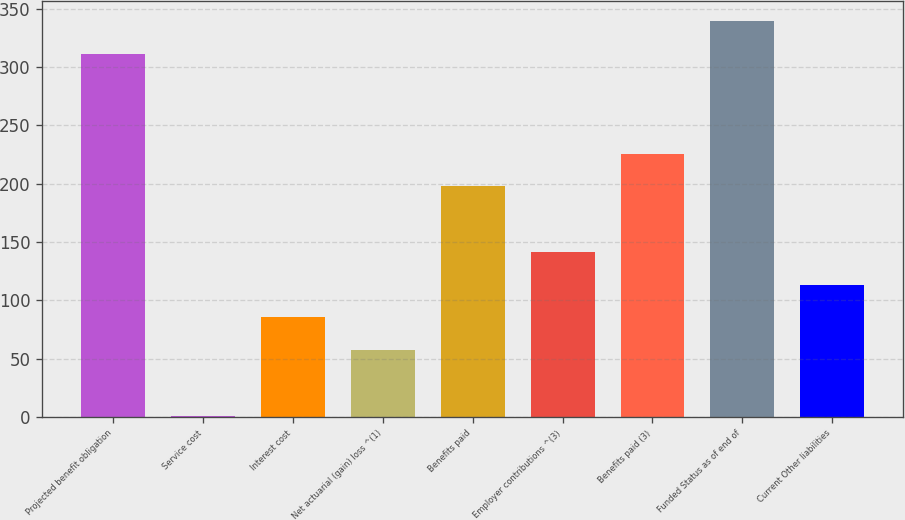<chart> <loc_0><loc_0><loc_500><loc_500><bar_chart><fcel>Projected benefit obligation<fcel>Service cost<fcel>Interest cost<fcel>Net actuarial (gain) loss ^(1)<fcel>Benefits paid<fcel>Employer contributions ^(3)<fcel>Benefits paid (3)<fcel>Funded Status as of end of<fcel>Current Other liabilities<nl><fcel>311.2<fcel>1<fcel>85.3<fcel>57.2<fcel>197.7<fcel>141.5<fcel>225.8<fcel>339.3<fcel>113.4<nl></chart> 